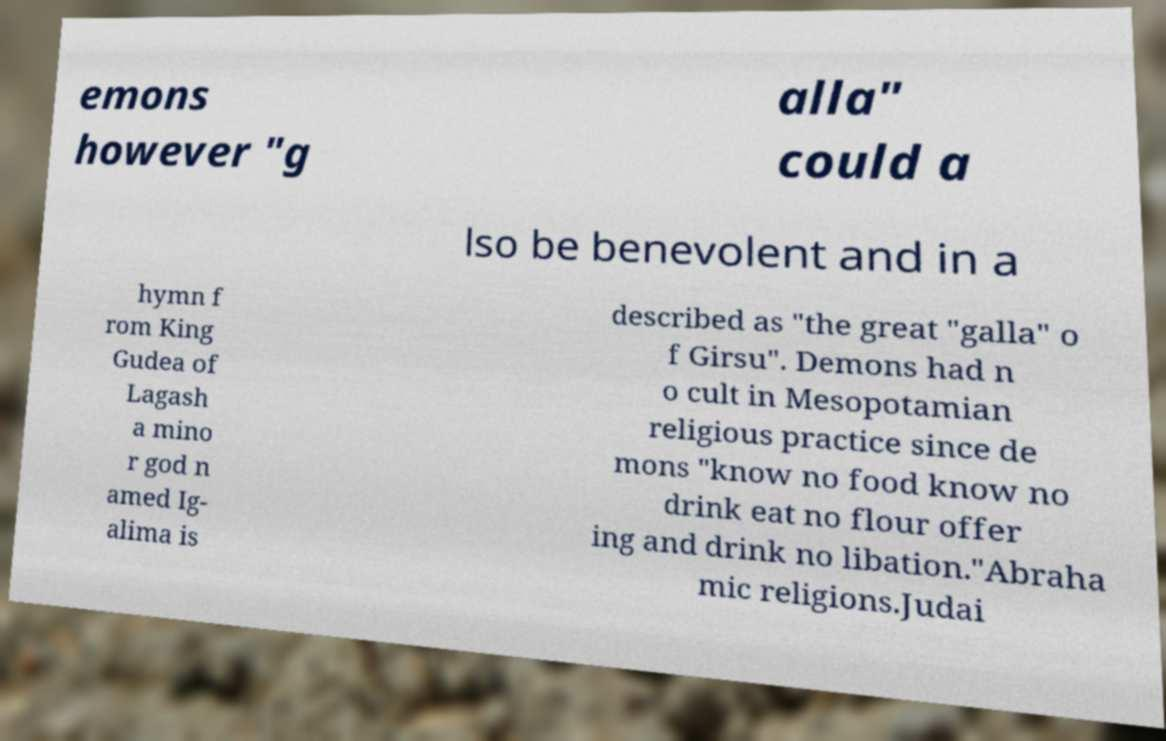I need the written content from this picture converted into text. Can you do that? emons however "g alla" could a lso be benevolent and in a hymn f rom King Gudea of Lagash a mino r god n amed Ig- alima is described as "the great "galla" o f Girsu". Demons had n o cult in Mesopotamian religious practice since de mons "know no food know no drink eat no flour offer ing and drink no libation."Abraha mic religions.Judai 